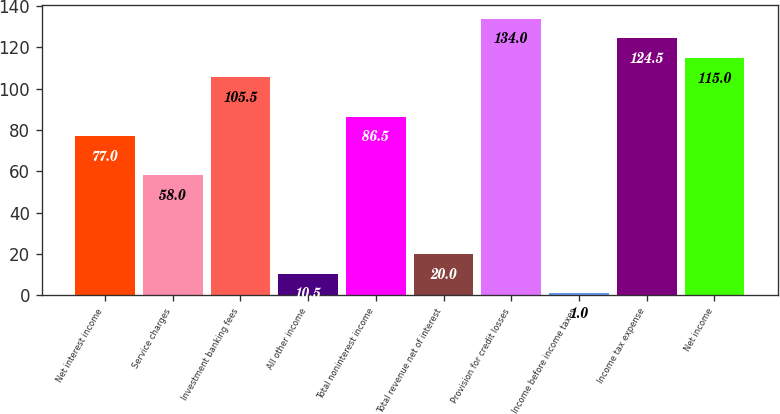Convert chart to OTSL. <chart><loc_0><loc_0><loc_500><loc_500><bar_chart><fcel>Net interest income<fcel>Service charges<fcel>Investment banking fees<fcel>All other income<fcel>Total noninterest income<fcel>Total revenue net of interest<fcel>Provision for credit losses<fcel>Income before income taxes<fcel>Income tax expense<fcel>Net income<nl><fcel>77<fcel>58<fcel>105.5<fcel>10.5<fcel>86.5<fcel>20<fcel>134<fcel>1<fcel>124.5<fcel>115<nl></chart> 